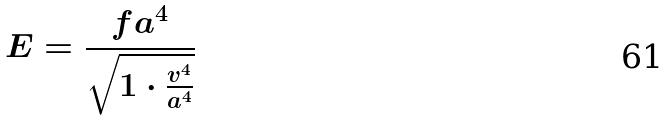<formula> <loc_0><loc_0><loc_500><loc_500>E = \frac { f a ^ { 4 } } { \sqrt { 1 \cdot \frac { v ^ { 4 } } { a ^ { 4 } } } }</formula> 